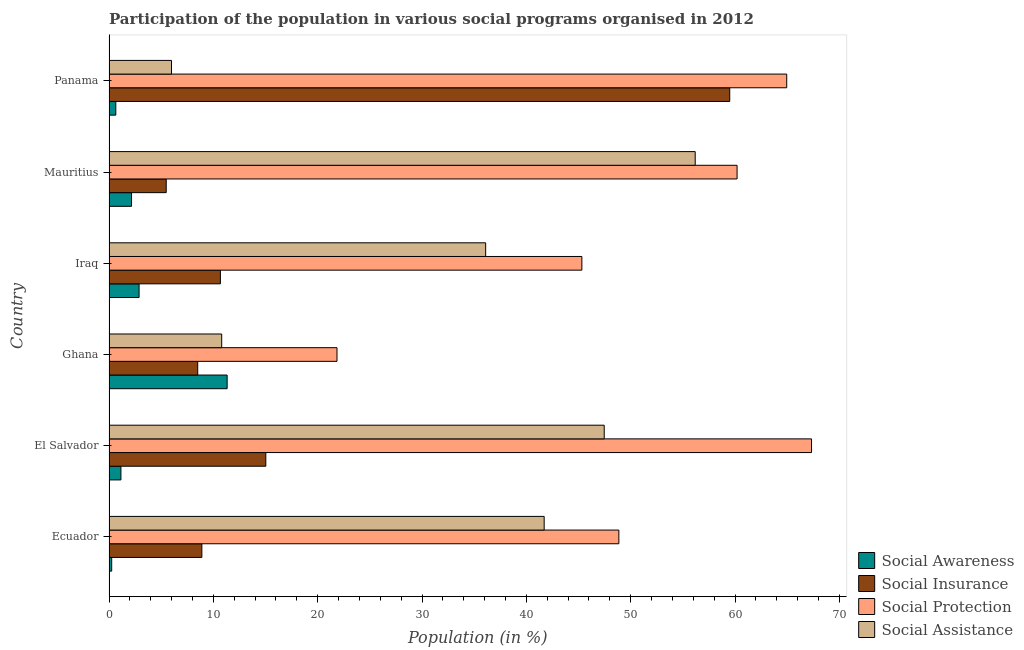How many different coloured bars are there?
Offer a terse response. 4. How many groups of bars are there?
Your answer should be compact. 6. Are the number of bars per tick equal to the number of legend labels?
Ensure brevity in your answer.  Yes. How many bars are there on the 1st tick from the bottom?
Your answer should be compact. 4. What is the label of the 5th group of bars from the top?
Provide a succinct answer. El Salvador. In how many cases, is the number of bars for a given country not equal to the number of legend labels?
Offer a very short reply. 0. What is the participation of population in social protection programs in Iraq?
Your answer should be compact. 45.32. Across all countries, what is the maximum participation of population in social protection programs?
Give a very brief answer. 67.33. Across all countries, what is the minimum participation of population in social assistance programs?
Give a very brief answer. 5.99. In which country was the participation of population in social assistance programs maximum?
Give a very brief answer. Mauritius. In which country was the participation of population in social insurance programs minimum?
Make the answer very short. Mauritius. What is the total participation of population in social protection programs in the graph?
Offer a very short reply. 308.51. What is the difference between the participation of population in social awareness programs in El Salvador and that in Ghana?
Offer a very short reply. -10.18. What is the difference between the participation of population in social assistance programs in Ghana and the participation of population in social protection programs in Iraq?
Your response must be concise. -34.52. What is the average participation of population in social protection programs per country?
Keep it short and to the point. 51.42. What is the difference between the participation of population in social assistance programs and participation of population in social awareness programs in Panama?
Give a very brief answer. 5.34. In how many countries, is the participation of population in social protection programs greater than 68 %?
Your answer should be very brief. 0. What is the ratio of the participation of population in social awareness programs in Ecuador to that in Iraq?
Provide a succinct answer. 0.09. What is the difference between the highest and the second highest participation of population in social protection programs?
Your response must be concise. 2.38. What is the difference between the highest and the lowest participation of population in social awareness programs?
Make the answer very short. 11.06. What does the 3rd bar from the top in Mauritius represents?
Provide a short and direct response. Social Insurance. What does the 3rd bar from the bottom in Ghana represents?
Offer a very short reply. Social Protection. Is it the case that in every country, the sum of the participation of population in social awareness programs and participation of population in social insurance programs is greater than the participation of population in social protection programs?
Offer a terse response. No. How many bars are there?
Ensure brevity in your answer.  24. How many countries are there in the graph?
Ensure brevity in your answer.  6. What is the difference between two consecutive major ticks on the X-axis?
Provide a short and direct response. 10. Where does the legend appear in the graph?
Offer a very short reply. Bottom right. How are the legend labels stacked?
Your answer should be very brief. Vertical. What is the title of the graph?
Offer a very short reply. Participation of the population in various social programs organised in 2012. What is the label or title of the X-axis?
Keep it short and to the point. Population (in %). What is the label or title of the Y-axis?
Provide a succinct answer. Country. What is the Population (in %) in Social Awareness in Ecuador?
Give a very brief answer. 0.26. What is the Population (in %) of Social Insurance in Ecuador?
Provide a succinct answer. 8.9. What is the Population (in %) of Social Protection in Ecuador?
Make the answer very short. 48.86. What is the Population (in %) in Social Assistance in Ecuador?
Make the answer very short. 41.71. What is the Population (in %) of Social Awareness in El Salvador?
Offer a terse response. 1.14. What is the Population (in %) of Social Insurance in El Salvador?
Your answer should be very brief. 15.03. What is the Population (in %) of Social Protection in El Salvador?
Give a very brief answer. 67.33. What is the Population (in %) in Social Assistance in El Salvador?
Ensure brevity in your answer.  47.46. What is the Population (in %) of Social Awareness in Ghana?
Ensure brevity in your answer.  11.32. What is the Population (in %) of Social Insurance in Ghana?
Keep it short and to the point. 8.5. What is the Population (in %) of Social Protection in Ghana?
Make the answer very short. 21.85. What is the Population (in %) of Social Assistance in Ghana?
Provide a short and direct response. 10.8. What is the Population (in %) of Social Awareness in Iraq?
Ensure brevity in your answer.  2.88. What is the Population (in %) of Social Insurance in Iraq?
Provide a succinct answer. 10.67. What is the Population (in %) in Social Protection in Iraq?
Keep it short and to the point. 45.32. What is the Population (in %) in Social Assistance in Iraq?
Your answer should be compact. 36.1. What is the Population (in %) in Social Awareness in Mauritius?
Give a very brief answer. 2.16. What is the Population (in %) in Social Insurance in Mauritius?
Provide a succinct answer. 5.48. What is the Population (in %) of Social Protection in Mauritius?
Provide a succinct answer. 60.19. What is the Population (in %) of Social Assistance in Mauritius?
Keep it short and to the point. 56.18. What is the Population (in %) in Social Awareness in Panama?
Give a very brief answer. 0.65. What is the Population (in %) in Social Insurance in Panama?
Your answer should be very brief. 59.49. What is the Population (in %) in Social Protection in Panama?
Offer a very short reply. 64.95. What is the Population (in %) in Social Assistance in Panama?
Offer a very short reply. 5.99. Across all countries, what is the maximum Population (in %) of Social Awareness?
Ensure brevity in your answer.  11.32. Across all countries, what is the maximum Population (in %) in Social Insurance?
Your response must be concise. 59.49. Across all countries, what is the maximum Population (in %) in Social Protection?
Ensure brevity in your answer.  67.33. Across all countries, what is the maximum Population (in %) of Social Assistance?
Offer a very short reply. 56.18. Across all countries, what is the minimum Population (in %) of Social Awareness?
Offer a very short reply. 0.26. Across all countries, what is the minimum Population (in %) of Social Insurance?
Provide a succinct answer. 5.48. Across all countries, what is the minimum Population (in %) in Social Protection?
Your answer should be compact. 21.85. Across all countries, what is the minimum Population (in %) of Social Assistance?
Ensure brevity in your answer.  5.99. What is the total Population (in %) in Social Awareness in the graph?
Ensure brevity in your answer.  18.41. What is the total Population (in %) of Social Insurance in the graph?
Offer a very short reply. 108.08. What is the total Population (in %) of Social Protection in the graph?
Offer a very short reply. 308.51. What is the total Population (in %) in Social Assistance in the graph?
Offer a very short reply. 198.23. What is the difference between the Population (in %) in Social Awareness in Ecuador and that in El Salvador?
Make the answer very short. -0.88. What is the difference between the Population (in %) in Social Insurance in Ecuador and that in El Salvador?
Keep it short and to the point. -6.13. What is the difference between the Population (in %) in Social Protection in Ecuador and that in El Salvador?
Make the answer very short. -18.47. What is the difference between the Population (in %) of Social Assistance in Ecuador and that in El Salvador?
Your answer should be compact. -5.76. What is the difference between the Population (in %) in Social Awareness in Ecuador and that in Ghana?
Your answer should be compact. -11.06. What is the difference between the Population (in %) in Social Insurance in Ecuador and that in Ghana?
Your answer should be compact. 0.4. What is the difference between the Population (in %) in Social Protection in Ecuador and that in Ghana?
Offer a terse response. 27.01. What is the difference between the Population (in %) of Social Assistance in Ecuador and that in Ghana?
Provide a succinct answer. 30.91. What is the difference between the Population (in %) in Social Awareness in Ecuador and that in Iraq?
Ensure brevity in your answer.  -2.62. What is the difference between the Population (in %) of Social Insurance in Ecuador and that in Iraq?
Offer a very short reply. -1.78. What is the difference between the Population (in %) in Social Protection in Ecuador and that in Iraq?
Your answer should be very brief. 3.54. What is the difference between the Population (in %) of Social Assistance in Ecuador and that in Iraq?
Offer a terse response. 5.61. What is the difference between the Population (in %) of Social Awareness in Ecuador and that in Mauritius?
Provide a succinct answer. -1.9. What is the difference between the Population (in %) of Social Insurance in Ecuador and that in Mauritius?
Your answer should be compact. 3.42. What is the difference between the Population (in %) in Social Protection in Ecuador and that in Mauritius?
Offer a very short reply. -11.33. What is the difference between the Population (in %) of Social Assistance in Ecuador and that in Mauritius?
Your answer should be compact. -14.48. What is the difference between the Population (in %) in Social Awareness in Ecuador and that in Panama?
Keep it short and to the point. -0.39. What is the difference between the Population (in %) in Social Insurance in Ecuador and that in Panama?
Make the answer very short. -50.59. What is the difference between the Population (in %) in Social Protection in Ecuador and that in Panama?
Make the answer very short. -16.09. What is the difference between the Population (in %) in Social Assistance in Ecuador and that in Panama?
Provide a short and direct response. 35.72. What is the difference between the Population (in %) in Social Awareness in El Salvador and that in Ghana?
Give a very brief answer. -10.18. What is the difference between the Population (in %) of Social Insurance in El Salvador and that in Ghana?
Provide a succinct answer. 6.53. What is the difference between the Population (in %) of Social Protection in El Salvador and that in Ghana?
Your answer should be compact. 45.48. What is the difference between the Population (in %) in Social Assistance in El Salvador and that in Ghana?
Give a very brief answer. 36.66. What is the difference between the Population (in %) in Social Awareness in El Salvador and that in Iraq?
Your answer should be compact. -1.74. What is the difference between the Population (in %) of Social Insurance in El Salvador and that in Iraq?
Your answer should be compact. 4.35. What is the difference between the Population (in %) of Social Protection in El Salvador and that in Iraq?
Your response must be concise. 22.01. What is the difference between the Population (in %) of Social Assistance in El Salvador and that in Iraq?
Offer a very short reply. 11.36. What is the difference between the Population (in %) of Social Awareness in El Salvador and that in Mauritius?
Your answer should be compact. -1.02. What is the difference between the Population (in %) in Social Insurance in El Salvador and that in Mauritius?
Give a very brief answer. 9.55. What is the difference between the Population (in %) of Social Protection in El Salvador and that in Mauritius?
Keep it short and to the point. 7.14. What is the difference between the Population (in %) of Social Assistance in El Salvador and that in Mauritius?
Your answer should be compact. -8.72. What is the difference between the Population (in %) in Social Awareness in El Salvador and that in Panama?
Provide a short and direct response. 0.49. What is the difference between the Population (in %) in Social Insurance in El Salvador and that in Panama?
Make the answer very short. -44.46. What is the difference between the Population (in %) of Social Protection in El Salvador and that in Panama?
Your response must be concise. 2.38. What is the difference between the Population (in %) of Social Assistance in El Salvador and that in Panama?
Your response must be concise. 41.47. What is the difference between the Population (in %) of Social Awareness in Ghana and that in Iraq?
Give a very brief answer. 8.44. What is the difference between the Population (in %) of Social Insurance in Ghana and that in Iraq?
Keep it short and to the point. -2.17. What is the difference between the Population (in %) in Social Protection in Ghana and that in Iraq?
Your answer should be compact. -23.47. What is the difference between the Population (in %) in Social Assistance in Ghana and that in Iraq?
Your answer should be very brief. -25.3. What is the difference between the Population (in %) of Social Awareness in Ghana and that in Mauritius?
Offer a very short reply. 9.16. What is the difference between the Population (in %) of Social Insurance in Ghana and that in Mauritius?
Provide a succinct answer. 3.02. What is the difference between the Population (in %) of Social Protection in Ghana and that in Mauritius?
Ensure brevity in your answer.  -38.34. What is the difference between the Population (in %) of Social Assistance in Ghana and that in Mauritius?
Give a very brief answer. -45.38. What is the difference between the Population (in %) of Social Awareness in Ghana and that in Panama?
Ensure brevity in your answer.  10.67. What is the difference between the Population (in %) of Social Insurance in Ghana and that in Panama?
Provide a short and direct response. -50.99. What is the difference between the Population (in %) of Social Protection in Ghana and that in Panama?
Your response must be concise. -43.1. What is the difference between the Population (in %) in Social Assistance in Ghana and that in Panama?
Keep it short and to the point. 4.81. What is the difference between the Population (in %) of Social Awareness in Iraq and that in Mauritius?
Your response must be concise. 0.72. What is the difference between the Population (in %) in Social Insurance in Iraq and that in Mauritius?
Ensure brevity in your answer.  5.19. What is the difference between the Population (in %) of Social Protection in Iraq and that in Mauritius?
Give a very brief answer. -14.87. What is the difference between the Population (in %) of Social Assistance in Iraq and that in Mauritius?
Give a very brief answer. -20.08. What is the difference between the Population (in %) in Social Awareness in Iraq and that in Panama?
Keep it short and to the point. 2.23. What is the difference between the Population (in %) in Social Insurance in Iraq and that in Panama?
Provide a short and direct response. -48.82. What is the difference between the Population (in %) of Social Protection in Iraq and that in Panama?
Ensure brevity in your answer.  -19.63. What is the difference between the Population (in %) in Social Assistance in Iraq and that in Panama?
Ensure brevity in your answer.  30.11. What is the difference between the Population (in %) of Social Awareness in Mauritius and that in Panama?
Offer a very short reply. 1.51. What is the difference between the Population (in %) in Social Insurance in Mauritius and that in Panama?
Ensure brevity in your answer.  -54.01. What is the difference between the Population (in %) in Social Protection in Mauritius and that in Panama?
Your response must be concise. -4.76. What is the difference between the Population (in %) of Social Assistance in Mauritius and that in Panama?
Offer a terse response. 50.19. What is the difference between the Population (in %) of Social Awareness in Ecuador and the Population (in %) of Social Insurance in El Salvador?
Make the answer very short. -14.77. What is the difference between the Population (in %) in Social Awareness in Ecuador and the Population (in %) in Social Protection in El Salvador?
Provide a short and direct response. -67.07. What is the difference between the Population (in %) in Social Awareness in Ecuador and the Population (in %) in Social Assistance in El Salvador?
Offer a very short reply. -47.2. What is the difference between the Population (in %) of Social Insurance in Ecuador and the Population (in %) of Social Protection in El Salvador?
Your answer should be compact. -58.43. What is the difference between the Population (in %) of Social Insurance in Ecuador and the Population (in %) of Social Assistance in El Salvador?
Your answer should be very brief. -38.56. What is the difference between the Population (in %) in Social Protection in Ecuador and the Population (in %) in Social Assistance in El Salvador?
Give a very brief answer. 1.4. What is the difference between the Population (in %) of Social Awareness in Ecuador and the Population (in %) of Social Insurance in Ghana?
Provide a short and direct response. -8.24. What is the difference between the Population (in %) of Social Awareness in Ecuador and the Population (in %) of Social Protection in Ghana?
Ensure brevity in your answer.  -21.59. What is the difference between the Population (in %) of Social Awareness in Ecuador and the Population (in %) of Social Assistance in Ghana?
Your answer should be compact. -10.54. What is the difference between the Population (in %) of Social Insurance in Ecuador and the Population (in %) of Social Protection in Ghana?
Your answer should be compact. -12.95. What is the difference between the Population (in %) of Social Insurance in Ecuador and the Population (in %) of Social Assistance in Ghana?
Provide a succinct answer. -1.9. What is the difference between the Population (in %) of Social Protection in Ecuador and the Population (in %) of Social Assistance in Ghana?
Your answer should be very brief. 38.06. What is the difference between the Population (in %) of Social Awareness in Ecuador and the Population (in %) of Social Insurance in Iraq?
Provide a succinct answer. -10.42. What is the difference between the Population (in %) of Social Awareness in Ecuador and the Population (in %) of Social Protection in Iraq?
Your response must be concise. -45.06. What is the difference between the Population (in %) of Social Awareness in Ecuador and the Population (in %) of Social Assistance in Iraq?
Make the answer very short. -35.84. What is the difference between the Population (in %) in Social Insurance in Ecuador and the Population (in %) in Social Protection in Iraq?
Your response must be concise. -36.42. What is the difference between the Population (in %) of Social Insurance in Ecuador and the Population (in %) of Social Assistance in Iraq?
Provide a short and direct response. -27.2. What is the difference between the Population (in %) of Social Protection in Ecuador and the Population (in %) of Social Assistance in Iraq?
Your response must be concise. 12.77. What is the difference between the Population (in %) in Social Awareness in Ecuador and the Population (in %) in Social Insurance in Mauritius?
Make the answer very short. -5.23. What is the difference between the Population (in %) in Social Awareness in Ecuador and the Population (in %) in Social Protection in Mauritius?
Provide a succinct answer. -59.94. What is the difference between the Population (in %) of Social Awareness in Ecuador and the Population (in %) of Social Assistance in Mauritius?
Provide a succinct answer. -55.92. What is the difference between the Population (in %) of Social Insurance in Ecuador and the Population (in %) of Social Protection in Mauritius?
Your answer should be compact. -51.3. What is the difference between the Population (in %) in Social Insurance in Ecuador and the Population (in %) in Social Assistance in Mauritius?
Your answer should be compact. -47.28. What is the difference between the Population (in %) in Social Protection in Ecuador and the Population (in %) in Social Assistance in Mauritius?
Offer a terse response. -7.32. What is the difference between the Population (in %) in Social Awareness in Ecuador and the Population (in %) in Social Insurance in Panama?
Offer a terse response. -59.23. What is the difference between the Population (in %) of Social Awareness in Ecuador and the Population (in %) of Social Protection in Panama?
Your response must be concise. -64.7. What is the difference between the Population (in %) of Social Awareness in Ecuador and the Population (in %) of Social Assistance in Panama?
Make the answer very short. -5.73. What is the difference between the Population (in %) of Social Insurance in Ecuador and the Population (in %) of Social Protection in Panama?
Your answer should be very brief. -56.05. What is the difference between the Population (in %) of Social Insurance in Ecuador and the Population (in %) of Social Assistance in Panama?
Your answer should be compact. 2.91. What is the difference between the Population (in %) in Social Protection in Ecuador and the Population (in %) in Social Assistance in Panama?
Your response must be concise. 42.88. What is the difference between the Population (in %) in Social Awareness in El Salvador and the Population (in %) in Social Insurance in Ghana?
Give a very brief answer. -7.36. What is the difference between the Population (in %) of Social Awareness in El Salvador and the Population (in %) of Social Protection in Ghana?
Offer a terse response. -20.71. What is the difference between the Population (in %) in Social Awareness in El Salvador and the Population (in %) in Social Assistance in Ghana?
Provide a short and direct response. -9.66. What is the difference between the Population (in %) in Social Insurance in El Salvador and the Population (in %) in Social Protection in Ghana?
Keep it short and to the point. -6.82. What is the difference between the Population (in %) in Social Insurance in El Salvador and the Population (in %) in Social Assistance in Ghana?
Provide a succinct answer. 4.23. What is the difference between the Population (in %) of Social Protection in El Salvador and the Population (in %) of Social Assistance in Ghana?
Offer a terse response. 56.53. What is the difference between the Population (in %) of Social Awareness in El Salvador and the Population (in %) of Social Insurance in Iraq?
Offer a terse response. -9.53. What is the difference between the Population (in %) of Social Awareness in El Salvador and the Population (in %) of Social Protection in Iraq?
Your answer should be compact. -44.18. What is the difference between the Population (in %) in Social Awareness in El Salvador and the Population (in %) in Social Assistance in Iraq?
Your response must be concise. -34.96. What is the difference between the Population (in %) of Social Insurance in El Salvador and the Population (in %) of Social Protection in Iraq?
Offer a terse response. -30.29. What is the difference between the Population (in %) in Social Insurance in El Salvador and the Population (in %) in Social Assistance in Iraq?
Give a very brief answer. -21.07. What is the difference between the Population (in %) in Social Protection in El Salvador and the Population (in %) in Social Assistance in Iraq?
Give a very brief answer. 31.23. What is the difference between the Population (in %) of Social Awareness in El Salvador and the Population (in %) of Social Insurance in Mauritius?
Keep it short and to the point. -4.34. What is the difference between the Population (in %) in Social Awareness in El Salvador and the Population (in %) in Social Protection in Mauritius?
Provide a succinct answer. -59.05. What is the difference between the Population (in %) of Social Awareness in El Salvador and the Population (in %) of Social Assistance in Mauritius?
Provide a succinct answer. -55.04. What is the difference between the Population (in %) in Social Insurance in El Salvador and the Population (in %) in Social Protection in Mauritius?
Offer a terse response. -45.17. What is the difference between the Population (in %) of Social Insurance in El Salvador and the Population (in %) of Social Assistance in Mauritius?
Provide a succinct answer. -41.15. What is the difference between the Population (in %) in Social Protection in El Salvador and the Population (in %) in Social Assistance in Mauritius?
Keep it short and to the point. 11.15. What is the difference between the Population (in %) in Social Awareness in El Salvador and the Population (in %) in Social Insurance in Panama?
Keep it short and to the point. -58.35. What is the difference between the Population (in %) in Social Awareness in El Salvador and the Population (in %) in Social Protection in Panama?
Provide a short and direct response. -63.81. What is the difference between the Population (in %) of Social Awareness in El Salvador and the Population (in %) of Social Assistance in Panama?
Your answer should be very brief. -4.85. What is the difference between the Population (in %) of Social Insurance in El Salvador and the Population (in %) of Social Protection in Panama?
Offer a very short reply. -49.92. What is the difference between the Population (in %) in Social Insurance in El Salvador and the Population (in %) in Social Assistance in Panama?
Make the answer very short. 9.04. What is the difference between the Population (in %) in Social Protection in El Salvador and the Population (in %) in Social Assistance in Panama?
Ensure brevity in your answer.  61.34. What is the difference between the Population (in %) of Social Awareness in Ghana and the Population (in %) of Social Insurance in Iraq?
Your answer should be compact. 0.65. What is the difference between the Population (in %) in Social Awareness in Ghana and the Population (in %) in Social Protection in Iraq?
Your answer should be very brief. -34. What is the difference between the Population (in %) in Social Awareness in Ghana and the Population (in %) in Social Assistance in Iraq?
Your response must be concise. -24.78. What is the difference between the Population (in %) in Social Insurance in Ghana and the Population (in %) in Social Protection in Iraq?
Your response must be concise. -36.82. What is the difference between the Population (in %) of Social Insurance in Ghana and the Population (in %) of Social Assistance in Iraq?
Provide a short and direct response. -27.6. What is the difference between the Population (in %) of Social Protection in Ghana and the Population (in %) of Social Assistance in Iraq?
Provide a short and direct response. -14.25. What is the difference between the Population (in %) of Social Awareness in Ghana and the Population (in %) of Social Insurance in Mauritius?
Provide a succinct answer. 5.84. What is the difference between the Population (in %) of Social Awareness in Ghana and the Population (in %) of Social Protection in Mauritius?
Provide a succinct answer. -48.87. What is the difference between the Population (in %) of Social Awareness in Ghana and the Population (in %) of Social Assistance in Mauritius?
Ensure brevity in your answer.  -44.86. What is the difference between the Population (in %) in Social Insurance in Ghana and the Population (in %) in Social Protection in Mauritius?
Make the answer very short. -51.69. What is the difference between the Population (in %) of Social Insurance in Ghana and the Population (in %) of Social Assistance in Mauritius?
Your answer should be compact. -47.68. What is the difference between the Population (in %) in Social Protection in Ghana and the Population (in %) in Social Assistance in Mauritius?
Your answer should be compact. -34.33. What is the difference between the Population (in %) in Social Awareness in Ghana and the Population (in %) in Social Insurance in Panama?
Provide a succinct answer. -48.17. What is the difference between the Population (in %) of Social Awareness in Ghana and the Population (in %) of Social Protection in Panama?
Offer a very short reply. -53.63. What is the difference between the Population (in %) of Social Awareness in Ghana and the Population (in %) of Social Assistance in Panama?
Your answer should be compact. 5.33. What is the difference between the Population (in %) in Social Insurance in Ghana and the Population (in %) in Social Protection in Panama?
Your answer should be very brief. -56.45. What is the difference between the Population (in %) in Social Insurance in Ghana and the Population (in %) in Social Assistance in Panama?
Keep it short and to the point. 2.51. What is the difference between the Population (in %) in Social Protection in Ghana and the Population (in %) in Social Assistance in Panama?
Provide a short and direct response. 15.86. What is the difference between the Population (in %) in Social Awareness in Iraq and the Population (in %) in Social Insurance in Mauritius?
Offer a terse response. -2.6. What is the difference between the Population (in %) of Social Awareness in Iraq and the Population (in %) of Social Protection in Mauritius?
Provide a short and direct response. -57.31. What is the difference between the Population (in %) of Social Awareness in Iraq and the Population (in %) of Social Assistance in Mauritius?
Your answer should be very brief. -53.3. What is the difference between the Population (in %) of Social Insurance in Iraq and the Population (in %) of Social Protection in Mauritius?
Your answer should be compact. -49.52. What is the difference between the Population (in %) of Social Insurance in Iraq and the Population (in %) of Social Assistance in Mauritius?
Make the answer very short. -45.51. What is the difference between the Population (in %) in Social Protection in Iraq and the Population (in %) in Social Assistance in Mauritius?
Give a very brief answer. -10.86. What is the difference between the Population (in %) in Social Awareness in Iraq and the Population (in %) in Social Insurance in Panama?
Give a very brief answer. -56.61. What is the difference between the Population (in %) in Social Awareness in Iraq and the Population (in %) in Social Protection in Panama?
Your response must be concise. -62.07. What is the difference between the Population (in %) in Social Awareness in Iraq and the Population (in %) in Social Assistance in Panama?
Make the answer very short. -3.11. What is the difference between the Population (in %) in Social Insurance in Iraq and the Population (in %) in Social Protection in Panama?
Offer a terse response. -54.28. What is the difference between the Population (in %) of Social Insurance in Iraq and the Population (in %) of Social Assistance in Panama?
Offer a very short reply. 4.69. What is the difference between the Population (in %) of Social Protection in Iraq and the Population (in %) of Social Assistance in Panama?
Offer a terse response. 39.33. What is the difference between the Population (in %) of Social Awareness in Mauritius and the Population (in %) of Social Insurance in Panama?
Your response must be concise. -57.33. What is the difference between the Population (in %) in Social Awareness in Mauritius and the Population (in %) in Social Protection in Panama?
Make the answer very short. -62.79. What is the difference between the Population (in %) in Social Awareness in Mauritius and the Population (in %) in Social Assistance in Panama?
Make the answer very short. -3.83. What is the difference between the Population (in %) in Social Insurance in Mauritius and the Population (in %) in Social Protection in Panama?
Your answer should be very brief. -59.47. What is the difference between the Population (in %) of Social Insurance in Mauritius and the Population (in %) of Social Assistance in Panama?
Offer a terse response. -0.51. What is the difference between the Population (in %) of Social Protection in Mauritius and the Population (in %) of Social Assistance in Panama?
Keep it short and to the point. 54.21. What is the average Population (in %) of Social Awareness per country?
Give a very brief answer. 3.07. What is the average Population (in %) of Social Insurance per country?
Offer a very short reply. 18.01. What is the average Population (in %) in Social Protection per country?
Offer a very short reply. 51.42. What is the average Population (in %) in Social Assistance per country?
Make the answer very short. 33.04. What is the difference between the Population (in %) in Social Awareness and Population (in %) in Social Insurance in Ecuador?
Give a very brief answer. -8.64. What is the difference between the Population (in %) in Social Awareness and Population (in %) in Social Protection in Ecuador?
Ensure brevity in your answer.  -48.61. What is the difference between the Population (in %) of Social Awareness and Population (in %) of Social Assistance in Ecuador?
Your response must be concise. -41.45. What is the difference between the Population (in %) in Social Insurance and Population (in %) in Social Protection in Ecuador?
Your answer should be compact. -39.97. What is the difference between the Population (in %) in Social Insurance and Population (in %) in Social Assistance in Ecuador?
Provide a short and direct response. -32.81. What is the difference between the Population (in %) in Social Protection and Population (in %) in Social Assistance in Ecuador?
Ensure brevity in your answer.  7.16. What is the difference between the Population (in %) of Social Awareness and Population (in %) of Social Insurance in El Salvador?
Offer a terse response. -13.89. What is the difference between the Population (in %) of Social Awareness and Population (in %) of Social Protection in El Salvador?
Keep it short and to the point. -66.19. What is the difference between the Population (in %) of Social Awareness and Population (in %) of Social Assistance in El Salvador?
Your response must be concise. -46.32. What is the difference between the Population (in %) in Social Insurance and Population (in %) in Social Protection in El Salvador?
Your response must be concise. -52.3. What is the difference between the Population (in %) of Social Insurance and Population (in %) of Social Assistance in El Salvador?
Offer a very short reply. -32.43. What is the difference between the Population (in %) of Social Protection and Population (in %) of Social Assistance in El Salvador?
Your answer should be compact. 19.87. What is the difference between the Population (in %) in Social Awareness and Population (in %) in Social Insurance in Ghana?
Your answer should be very brief. 2.82. What is the difference between the Population (in %) of Social Awareness and Population (in %) of Social Protection in Ghana?
Give a very brief answer. -10.53. What is the difference between the Population (in %) of Social Awareness and Population (in %) of Social Assistance in Ghana?
Make the answer very short. 0.52. What is the difference between the Population (in %) of Social Insurance and Population (in %) of Social Protection in Ghana?
Give a very brief answer. -13.35. What is the difference between the Population (in %) of Social Insurance and Population (in %) of Social Assistance in Ghana?
Make the answer very short. -2.3. What is the difference between the Population (in %) of Social Protection and Population (in %) of Social Assistance in Ghana?
Your answer should be compact. 11.05. What is the difference between the Population (in %) of Social Awareness and Population (in %) of Social Insurance in Iraq?
Give a very brief answer. -7.79. What is the difference between the Population (in %) in Social Awareness and Population (in %) in Social Protection in Iraq?
Offer a terse response. -42.44. What is the difference between the Population (in %) of Social Awareness and Population (in %) of Social Assistance in Iraq?
Your answer should be compact. -33.22. What is the difference between the Population (in %) in Social Insurance and Population (in %) in Social Protection in Iraq?
Offer a terse response. -34.65. What is the difference between the Population (in %) in Social Insurance and Population (in %) in Social Assistance in Iraq?
Your answer should be very brief. -25.42. What is the difference between the Population (in %) of Social Protection and Population (in %) of Social Assistance in Iraq?
Your answer should be compact. 9.22. What is the difference between the Population (in %) of Social Awareness and Population (in %) of Social Insurance in Mauritius?
Your answer should be very brief. -3.32. What is the difference between the Population (in %) of Social Awareness and Population (in %) of Social Protection in Mauritius?
Make the answer very short. -58.03. What is the difference between the Population (in %) in Social Awareness and Population (in %) in Social Assistance in Mauritius?
Your response must be concise. -54.02. What is the difference between the Population (in %) of Social Insurance and Population (in %) of Social Protection in Mauritius?
Provide a short and direct response. -54.71. What is the difference between the Population (in %) of Social Insurance and Population (in %) of Social Assistance in Mauritius?
Keep it short and to the point. -50.7. What is the difference between the Population (in %) in Social Protection and Population (in %) in Social Assistance in Mauritius?
Your response must be concise. 4.01. What is the difference between the Population (in %) of Social Awareness and Population (in %) of Social Insurance in Panama?
Offer a very short reply. -58.84. What is the difference between the Population (in %) in Social Awareness and Population (in %) in Social Protection in Panama?
Ensure brevity in your answer.  -64.3. What is the difference between the Population (in %) in Social Awareness and Population (in %) in Social Assistance in Panama?
Provide a succinct answer. -5.34. What is the difference between the Population (in %) in Social Insurance and Population (in %) in Social Protection in Panama?
Your answer should be very brief. -5.46. What is the difference between the Population (in %) of Social Insurance and Population (in %) of Social Assistance in Panama?
Offer a terse response. 53.5. What is the difference between the Population (in %) of Social Protection and Population (in %) of Social Assistance in Panama?
Your response must be concise. 58.96. What is the ratio of the Population (in %) of Social Awareness in Ecuador to that in El Salvador?
Provide a succinct answer. 0.23. What is the ratio of the Population (in %) of Social Insurance in Ecuador to that in El Salvador?
Provide a short and direct response. 0.59. What is the ratio of the Population (in %) of Social Protection in Ecuador to that in El Salvador?
Your answer should be very brief. 0.73. What is the ratio of the Population (in %) in Social Assistance in Ecuador to that in El Salvador?
Offer a terse response. 0.88. What is the ratio of the Population (in %) of Social Awareness in Ecuador to that in Ghana?
Your answer should be very brief. 0.02. What is the ratio of the Population (in %) of Social Insurance in Ecuador to that in Ghana?
Provide a succinct answer. 1.05. What is the ratio of the Population (in %) of Social Protection in Ecuador to that in Ghana?
Make the answer very short. 2.24. What is the ratio of the Population (in %) in Social Assistance in Ecuador to that in Ghana?
Offer a very short reply. 3.86. What is the ratio of the Population (in %) in Social Awareness in Ecuador to that in Iraq?
Give a very brief answer. 0.09. What is the ratio of the Population (in %) in Social Insurance in Ecuador to that in Iraq?
Make the answer very short. 0.83. What is the ratio of the Population (in %) in Social Protection in Ecuador to that in Iraq?
Give a very brief answer. 1.08. What is the ratio of the Population (in %) of Social Assistance in Ecuador to that in Iraq?
Provide a succinct answer. 1.16. What is the ratio of the Population (in %) of Social Awareness in Ecuador to that in Mauritius?
Provide a short and direct response. 0.12. What is the ratio of the Population (in %) of Social Insurance in Ecuador to that in Mauritius?
Keep it short and to the point. 1.62. What is the ratio of the Population (in %) in Social Protection in Ecuador to that in Mauritius?
Make the answer very short. 0.81. What is the ratio of the Population (in %) in Social Assistance in Ecuador to that in Mauritius?
Your answer should be compact. 0.74. What is the ratio of the Population (in %) in Social Awareness in Ecuador to that in Panama?
Keep it short and to the point. 0.4. What is the ratio of the Population (in %) in Social Insurance in Ecuador to that in Panama?
Provide a short and direct response. 0.15. What is the ratio of the Population (in %) of Social Protection in Ecuador to that in Panama?
Keep it short and to the point. 0.75. What is the ratio of the Population (in %) of Social Assistance in Ecuador to that in Panama?
Provide a short and direct response. 6.96. What is the ratio of the Population (in %) of Social Awareness in El Salvador to that in Ghana?
Keep it short and to the point. 0.1. What is the ratio of the Population (in %) of Social Insurance in El Salvador to that in Ghana?
Keep it short and to the point. 1.77. What is the ratio of the Population (in %) in Social Protection in El Salvador to that in Ghana?
Provide a succinct answer. 3.08. What is the ratio of the Population (in %) of Social Assistance in El Salvador to that in Ghana?
Make the answer very short. 4.39. What is the ratio of the Population (in %) in Social Awareness in El Salvador to that in Iraq?
Make the answer very short. 0.4. What is the ratio of the Population (in %) of Social Insurance in El Salvador to that in Iraq?
Your answer should be very brief. 1.41. What is the ratio of the Population (in %) of Social Protection in El Salvador to that in Iraq?
Provide a succinct answer. 1.49. What is the ratio of the Population (in %) of Social Assistance in El Salvador to that in Iraq?
Give a very brief answer. 1.31. What is the ratio of the Population (in %) in Social Awareness in El Salvador to that in Mauritius?
Keep it short and to the point. 0.53. What is the ratio of the Population (in %) of Social Insurance in El Salvador to that in Mauritius?
Offer a terse response. 2.74. What is the ratio of the Population (in %) of Social Protection in El Salvador to that in Mauritius?
Make the answer very short. 1.12. What is the ratio of the Population (in %) of Social Assistance in El Salvador to that in Mauritius?
Ensure brevity in your answer.  0.84. What is the ratio of the Population (in %) in Social Awareness in El Salvador to that in Panama?
Provide a succinct answer. 1.76. What is the ratio of the Population (in %) in Social Insurance in El Salvador to that in Panama?
Your answer should be very brief. 0.25. What is the ratio of the Population (in %) of Social Protection in El Salvador to that in Panama?
Make the answer very short. 1.04. What is the ratio of the Population (in %) in Social Assistance in El Salvador to that in Panama?
Your response must be concise. 7.92. What is the ratio of the Population (in %) of Social Awareness in Ghana to that in Iraq?
Give a very brief answer. 3.93. What is the ratio of the Population (in %) of Social Insurance in Ghana to that in Iraq?
Offer a very short reply. 0.8. What is the ratio of the Population (in %) of Social Protection in Ghana to that in Iraq?
Give a very brief answer. 0.48. What is the ratio of the Population (in %) in Social Assistance in Ghana to that in Iraq?
Make the answer very short. 0.3. What is the ratio of the Population (in %) in Social Awareness in Ghana to that in Mauritius?
Ensure brevity in your answer.  5.24. What is the ratio of the Population (in %) in Social Insurance in Ghana to that in Mauritius?
Keep it short and to the point. 1.55. What is the ratio of the Population (in %) in Social Protection in Ghana to that in Mauritius?
Offer a very short reply. 0.36. What is the ratio of the Population (in %) of Social Assistance in Ghana to that in Mauritius?
Provide a succinct answer. 0.19. What is the ratio of the Population (in %) of Social Awareness in Ghana to that in Panama?
Make the answer very short. 17.43. What is the ratio of the Population (in %) of Social Insurance in Ghana to that in Panama?
Give a very brief answer. 0.14. What is the ratio of the Population (in %) in Social Protection in Ghana to that in Panama?
Give a very brief answer. 0.34. What is the ratio of the Population (in %) in Social Assistance in Ghana to that in Panama?
Provide a short and direct response. 1.8. What is the ratio of the Population (in %) of Social Awareness in Iraq to that in Mauritius?
Give a very brief answer. 1.33. What is the ratio of the Population (in %) in Social Insurance in Iraq to that in Mauritius?
Provide a succinct answer. 1.95. What is the ratio of the Population (in %) in Social Protection in Iraq to that in Mauritius?
Provide a short and direct response. 0.75. What is the ratio of the Population (in %) of Social Assistance in Iraq to that in Mauritius?
Make the answer very short. 0.64. What is the ratio of the Population (in %) in Social Awareness in Iraq to that in Panama?
Offer a very short reply. 4.44. What is the ratio of the Population (in %) of Social Insurance in Iraq to that in Panama?
Your answer should be very brief. 0.18. What is the ratio of the Population (in %) in Social Protection in Iraq to that in Panama?
Ensure brevity in your answer.  0.7. What is the ratio of the Population (in %) in Social Assistance in Iraq to that in Panama?
Ensure brevity in your answer.  6.03. What is the ratio of the Population (in %) of Social Awareness in Mauritius to that in Panama?
Offer a terse response. 3.33. What is the ratio of the Population (in %) in Social Insurance in Mauritius to that in Panama?
Ensure brevity in your answer.  0.09. What is the ratio of the Population (in %) in Social Protection in Mauritius to that in Panama?
Keep it short and to the point. 0.93. What is the ratio of the Population (in %) in Social Assistance in Mauritius to that in Panama?
Offer a terse response. 9.38. What is the difference between the highest and the second highest Population (in %) in Social Awareness?
Ensure brevity in your answer.  8.44. What is the difference between the highest and the second highest Population (in %) of Social Insurance?
Give a very brief answer. 44.46. What is the difference between the highest and the second highest Population (in %) of Social Protection?
Your answer should be very brief. 2.38. What is the difference between the highest and the second highest Population (in %) in Social Assistance?
Offer a terse response. 8.72. What is the difference between the highest and the lowest Population (in %) in Social Awareness?
Offer a very short reply. 11.06. What is the difference between the highest and the lowest Population (in %) of Social Insurance?
Your response must be concise. 54.01. What is the difference between the highest and the lowest Population (in %) in Social Protection?
Offer a terse response. 45.48. What is the difference between the highest and the lowest Population (in %) of Social Assistance?
Offer a very short reply. 50.19. 